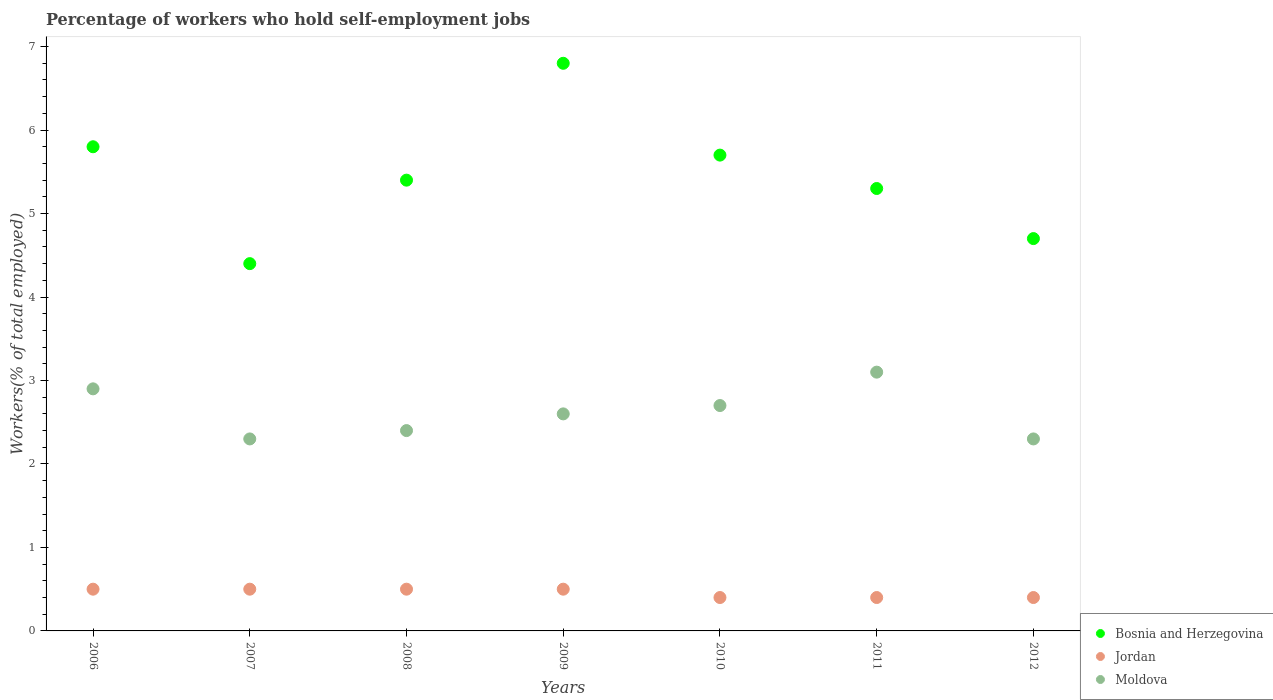How many different coloured dotlines are there?
Make the answer very short. 3. Is the number of dotlines equal to the number of legend labels?
Give a very brief answer. Yes. What is the percentage of self-employed workers in Jordan in 2011?
Keep it short and to the point. 0.4. Across all years, what is the maximum percentage of self-employed workers in Moldova?
Give a very brief answer. 3.1. Across all years, what is the minimum percentage of self-employed workers in Jordan?
Your response must be concise. 0.4. What is the total percentage of self-employed workers in Jordan in the graph?
Offer a very short reply. 3.2. What is the difference between the percentage of self-employed workers in Bosnia and Herzegovina in 2006 and that in 2011?
Give a very brief answer. 0.5. What is the difference between the percentage of self-employed workers in Jordan in 2011 and the percentage of self-employed workers in Moldova in 2010?
Offer a very short reply. -2.3. What is the average percentage of self-employed workers in Moldova per year?
Keep it short and to the point. 2.61. In the year 2012, what is the difference between the percentage of self-employed workers in Bosnia and Herzegovina and percentage of self-employed workers in Moldova?
Provide a succinct answer. 2.4. What is the ratio of the percentage of self-employed workers in Moldova in 2006 to that in 2008?
Provide a short and direct response. 1.21. Is the percentage of self-employed workers in Bosnia and Herzegovina in 2006 less than that in 2009?
Your response must be concise. Yes. Is the difference between the percentage of self-employed workers in Bosnia and Herzegovina in 2007 and 2008 greater than the difference between the percentage of self-employed workers in Moldova in 2007 and 2008?
Provide a succinct answer. No. What is the difference between the highest and the second highest percentage of self-employed workers in Moldova?
Ensure brevity in your answer.  0.2. What is the difference between the highest and the lowest percentage of self-employed workers in Bosnia and Herzegovina?
Make the answer very short. 2.4. In how many years, is the percentage of self-employed workers in Moldova greater than the average percentage of self-employed workers in Moldova taken over all years?
Make the answer very short. 3. How many dotlines are there?
Offer a very short reply. 3. Where does the legend appear in the graph?
Your answer should be very brief. Bottom right. How many legend labels are there?
Your answer should be very brief. 3. How are the legend labels stacked?
Your answer should be very brief. Vertical. What is the title of the graph?
Provide a succinct answer. Percentage of workers who hold self-employment jobs. Does "Norway" appear as one of the legend labels in the graph?
Give a very brief answer. No. What is the label or title of the Y-axis?
Provide a succinct answer. Workers(% of total employed). What is the Workers(% of total employed) in Bosnia and Herzegovina in 2006?
Offer a very short reply. 5.8. What is the Workers(% of total employed) of Jordan in 2006?
Keep it short and to the point. 0.5. What is the Workers(% of total employed) of Moldova in 2006?
Make the answer very short. 2.9. What is the Workers(% of total employed) in Bosnia and Herzegovina in 2007?
Your answer should be very brief. 4.4. What is the Workers(% of total employed) in Jordan in 2007?
Provide a short and direct response. 0.5. What is the Workers(% of total employed) of Moldova in 2007?
Offer a terse response. 2.3. What is the Workers(% of total employed) in Bosnia and Herzegovina in 2008?
Your response must be concise. 5.4. What is the Workers(% of total employed) in Moldova in 2008?
Your answer should be compact. 2.4. What is the Workers(% of total employed) in Bosnia and Herzegovina in 2009?
Your answer should be very brief. 6.8. What is the Workers(% of total employed) in Moldova in 2009?
Your answer should be compact. 2.6. What is the Workers(% of total employed) in Bosnia and Herzegovina in 2010?
Ensure brevity in your answer.  5.7. What is the Workers(% of total employed) of Jordan in 2010?
Make the answer very short. 0.4. What is the Workers(% of total employed) in Moldova in 2010?
Make the answer very short. 2.7. What is the Workers(% of total employed) in Bosnia and Herzegovina in 2011?
Offer a very short reply. 5.3. What is the Workers(% of total employed) in Jordan in 2011?
Provide a short and direct response. 0.4. What is the Workers(% of total employed) in Moldova in 2011?
Your response must be concise. 3.1. What is the Workers(% of total employed) of Bosnia and Herzegovina in 2012?
Keep it short and to the point. 4.7. What is the Workers(% of total employed) of Jordan in 2012?
Your response must be concise. 0.4. What is the Workers(% of total employed) in Moldova in 2012?
Give a very brief answer. 2.3. Across all years, what is the maximum Workers(% of total employed) of Bosnia and Herzegovina?
Make the answer very short. 6.8. Across all years, what is the maximum Workers(% of total employed) of Jordan?
Offer a terse response. 0.5. Across all years, what is the maximum Workers(% of total employed) in Moldova?
Keep it short and to the point. 3.1. Across all years, what is the minimum Workers(% of total employed) of Bosnia and Herzegovina?
Keep it short and to the point. 4.4. Across all years, what is the minimum Workers(% of total employed) in Jordan?
Keep it short and to the point. 0.4. Across all years, what is the minimum Workers(% of total employed) in Moldova?
Your response must be concise. 2.3. What is the total Workers(% of total employed) of Bosnia and Herzegovina in the graph?
Offer a very short reply. 38.1. What is the total Workers(% of total employed) in Jordan in the graph?
Provide a succinct answer. 3.2. What is the total Workers(% of total employed) of Moldova in the graph?
Offer a terse response. 18.3. What is the difference between the Workers(% of total employed) of Bosnia and Herzegovina in 2006 and that in 2007?
Your response must be concise. 1.4. What is the difference between the Workers(% of total employed) of Bosnia and Herzegovina in 2006 and that in 2008?
Your answer should be compact. 0.4. What is the difference between the Workers(% of total employed) in Jordan in 2006 and that in 2008?
Ensure brevity in your answer.  0. What is the difference between the Workers(% of total employed) in Jordan in 2006 and that in 2009?
Make the answer very short. 0. What is the difference between the Workers(% of total employed) of Moldova in 2006 and that in 2009?
Give a very brief answer. 0.3. What is the difference between the Workers(% of total employed) of Bosnia and Herzegovina in 2006 and that in 2010?
Provide a short and direct response. 0.1. What is the difference between the Workers(% of total employed) in Jordan in 2006 and that in 2010?
Your response must be concise. 0.1. What is the difference between the Workers(% of total employed) of Bosnia and Herzegovina in 2006 and that in 2011?
Your answer should be very brief. 0.5. What is the difference between the Workers(% of total employed) of Moldova in 2006 and that in 2012?
Provide a short and direct response. 0.6. What is the difference between the Workers(% of total employed) of Moldova in 2007 and that in 2009?
Offer a very short reply. -0.3. What is the difference between the Workers(% of total employed) of Jordan in 2007 and that in 2010?
Provide a succinct answer. 0.1. What is the difference between the Workers(% of total employed) of Moldova in 2007 and that in 2010?
Ensure brevity in your answer.  -0.4. What is the difference between the Workers(% of total employed) of Bosnia and Herzegovina in 2007 and that in 2012?
Your answer should be very brief. -0.3. What is the difference between the Workers(% of total employed) of Bosnia and Herzegovina in 2008 and that in 2010?
Your response must be concise. -0.3. What is the difference between the Workers(% of total employed) in Jordan in 2008 and that in 2010?
Your answer should be very brief. 0.1. What is the difference between the Workers(% of total employed) of Jordan in 2008 and that in 2011?
Your response must be concise. 0.1. What is the difference between the Workers(% of total employed) of Moldova in 2008 and that in 2011?
Your answer should be very brief. -0.7. What is the difference between the Workers(% of total employed) in Bosnia and Herzegovina in 2008 and that in 2012?
Ensure brevity in your answer.  0.7. What is the difference between the Workers(% of total employed) of Jordan in 2008 and that in 2012?
Give a very brief answer. 0.1. What is the difference between the Workers(% of total employed) in Bosnia and Herzegovina in 2009 and that in 2011?
Ensure brevity in your answer.  1.5. What is the difference between the Workers(% of total employed) in Bosnia and Herzegovina in 2010 and that in 2011?
Ensure brevity in your answer.  0.4. What is the difference between the Workers(% of total employed) of Jordan in 2010 and that in 2011?
Make the answer very short. 0. What is the difference between the Workers(% of total employed) in Bosnia and Herzegovina in 2010 and that in 2012?
Provide a short and direct response. 1. What is the difference between the Workers(% of total employed) in Jordan in 2010 and that in 2012?
Provide a succinct answer. 0. What is the difference between the Workers(% of total employed) of Moldova in 2010 and that in 2012?
Offer a terse response. 0.4. What is the difference between the Workers(% of total employed) in Bosnia and Herzegovina in 2011 and that in 2012?
Provide a short and direct response. 0.6. What is the difference between the Workers(% of total employed) in Jordan in 2011 and that in 2012?
Give a very brief answer. 0. What is the difference between the Workers(% of total employed) of Moldova in 2011 and that in 2012?
Provide a succinct answer. 0.8. What is the difference between the Workers(% of total employed) of Bosnia and Herzegovina in 2006 and the Workers(% of total employed) of Jordan in 2007?
Make the answer very short. 5.3. What is the difference between the Workers(% of total employed) in Bosnia and Herzegovina in 2006 and the Workers(% of total employed) in Moldova in 2007?
Your answer should be very brief. 3.5. What is the difference between the Workers(% of total employed) in Bosnia and Herzegovina in 2006 and the Workers(% of total employed) in Jordan in 2008?
Your answer should be very brief. 5.3. What is the difference between the Workers(% of total employed) in Bosnia and Herzegovina in 2006 and the Workers(% of total employed) in Moldova in 2008?
Make the answer very short. 3.4. What is the difference between the Workers(% of total employed) of Jordan in 2006 and the Workers(% of total employed) of Moldova in 2008?
Give a very brief answer. -1.9. What is the difference between the Workers(% of total employed) in Bosnia and Herzegovina in 2006 and the Workers(% of total employed) in Jordan in 2009?
Offer a very short reply. 5.3. What is the difference between the Workers(% of total employed) of Bosnia and Herzegovina in 2006 and the Workers(% of total employed) of Moldova in 2009?
Offer a terse response. 3.2. What is the difference between the Workers(% of total employed) in Jordan in 2006 and the Workers(% of total employed) in Moldova in 2009?
Your answer should be very brief. -2.1. What is the difference between the Workers(% of total employed) of Bosnia and Herzegovina in 2006 and the Workers(% of total employed) of Moldova in 2010?
Provide a short and direct response. 3.1. What is the difference between the Workers(% of total employed) in Bosnia and Herzegovina in 2006 and the Workers(% of total employed) in Jordan in 2011?
Your answer should be very brief. 5.4. What is the difference between the Workers(% of total employed) of Bosnia and Herzegovina in 2006 and the Workers(% of total employed) of Moldova in 2011?
Your response must be concise. 2.7. What is the difference between the Workers(% of total employed) of Jordan in 2006 and the Workers(% of total employed) of Moldova in 2011?
Keep it short and to the point. -2.6. What is the difference between the Workers(% of total employed) in Bosnia and Herzegovina in 2006 and the Workers(% of total employed) in Jordan in 2012?
Keep it short and to the point. 5.4. What is the difference between the Workers(% of total employed) in Bosnia and Herzegovina in 2006 and the Workers(% of total employed) in Moldova in 2012?
Make the answer very short. 3.5. What is the difference between the Workers(% of total employed) in Bosnia and Herzegovina in 2007 and the Workers(% of total employed) in Jordan in 2008?
Provide a short and direct response. 3.9. What is the difference between the Workers(% of total employed) of Bosnia and Herzegovina in 2007 and the Workers(% of total employed) of Moldova in 2008?
Offer a very short reply. 2. What is the difference between the Workers(% of total employed) of Bosnia and Herzegovina in 2007 and the Workers(% of total employed) of Moldova in 2009?
Keep it short and to the point. 1.8. What is the difference between the Workers(% of total employed) in Bosnia and Herzegovina in 2007 and the Workers(% of total employed) in Jordan in 2010?
Give a very brief answer. 4. What is the difference between the Workers(% of total employed) of Bosnia and Herzegovina in 2007 and the Workers(% of total employed) of Moldova in 2010?
Provide a succinct answer. 1.7. What is the difference between the Workers(% of total employed) in Jordan in 2007 and the Workers(% of total employed) in Moldova in 2010?
Give a very brief answer. -2.2. What is the difference between the Workers(% of total employed) in Bosnia and Herzegovina in 2007 and the Workers(% of total employed) in Moldova in 2011?
Offer a very short reply. 1.3. What is the difference between the Workers(% of total employed) of Jordan in 2007 and the Workers(% of total employed) of Moldova in 2011?
Keep it short and to the point. -2.6. What is the difference between the Workers(% of total employed) of Bosnia and Herzegovina in 2007 and the Workers(% of total employed) of Jordan in 2012?
Offer a terse response. 4. What is the difference between the Workers(% of total employed) in Bosnia and Herzegovina in 2007 and the Workers(% of total employed) in Moldova in 2012?
Keep it short and to the point. 2.1. What is the difference between the Workers(% of total employed) of Jordan in 2008 and the Workers(% of total employed) of Moldova in 2009?
Make the answer very short. -2.1. What is the difference between the Workers(% of total employed) of Bosnia and Herzegovina in 2008 and the Workers(% of total employed) of Jordan in 2010?
Offer a very short reply. 5. What is the difference between the Workers(% of total employed) of Bosnia and Herzegovina in 2008 and the Workers(% of total employed) of Moldova in 2010?
Provide a succinct answer. 2.7. What is the difference between the Workers(% of total employed) of Bosnia and Herzegovina in 2008 and the Workers(% of total employed) of Jordan in 2011?
Your answer should be compact. 5. What is the difference between the Workers(% of total employed) in Bosnia and Herzegovina in 2008 and the Workers(% of total employed) in Jordan in 2012?
Offer a terse response. 5. What is the difference between the Workers(% of total employed) of Bosnia and Herzegovina in 2008 and the Workers(% of total employed) of Moldova in 2012?
Your response must be concise. 3.1. What is the difference between the Workers(% of total employed) of Bosnia and Herzegovina in 2009 and the Workers(% of total employed) of Jordan in 2010?
Your response must be concise. 6.4. What is the difference between the Workers(% of total employed) of Bosnia and Herzegovina in 2009 and the Workers(% of total employed) of Jordan in 2011?
Provide a succinct answer. 6.4. What is the difference between the Workers(% of total employed) of Bosnia and Herzegovina in 2009 and the Workers(% of total employed) of Moldova in 2011?
Ensure brevity in your answer.  3.7. What is the difference between the Workers(% of total employed) in Jordan in 2009 and the Workers(% of total employed) in Moldova in 2012?
Provide a succinct answer. -1.8. What is the difference between the Workers(% of total employed) of Bosnia and Herzegovina in 2010 and the Workers(% of total employed) of Jordan in 2011?
Keep it short and to the point. 5.3. What is the difference between the Workers(% of total employed) of Bosnia and Herzegovina in 2010 and the Workers(% of total employed) of Moldova in 2011?
Your response must be concise. 2.6. What is the difference between the Workers(% of total employed) of Jordan in 2010 and the Workers(% of total employed) of Moldova in 2011?
Your response must be concise. -2.7. What is the difference between the Workers(% of total employed) in Bosnia and Herzegovina in 2011 and the Workers(% of total employed) in Jordan in 2012?
Give a very brief answer. 4.9. What is the average Workers(% of total employed) in Bosnia and Herzegovina per year?
Your response must be concise. 5.44. What is the average Workers(% of total employed) in Jordan per year?
Provide a short and direct response. 0.46. What is the average Workers(% of total employed) of Moldova per year?
Make the answer very short. 2.61. In the year 2008, what is the difference between the Workers(% of total employed) of Bosnia and Herzegovina and Workers(% of total employed) of Jordan?
Provide a succinct answer. 4.9. In the year 2008, what is the difference between the Workers(% of total employed) in Jordan and Workers(% of total employed) in Moldova?
Offer a terse response. -1.9. In the year 2009, what is the difference between the Workers(% of total employed) in Jordan and Workers(% of total employed) in Moldova?
Offer a very short reply. -2.1. In the year 2011, what is the difference between the Workers(% of total employed) of Bosnia and Herzegovina and Workers(% of total employed) of Jordan?
Ensure brevity in your answer.  4.9. In the year 2011, what is the difference between the Workers(% of total employed) of Bosnia and Herzegovina and Workers(% of total employed) of Moldova?
Offer a very short reply. 2.2. What is the ratio of the Workers(% of total employed) of Bosnia and Herzegovina in 2006 to that in 2007?
Provide a short and direct response. 1.32. What is the ratio of the Workers(% of total employed) of Jordan in 2006 to that in 2007?
Provide a short and direct response. 1. What is the ratio of the Workers(% of total employed) in Moldova in 2006 to that in 2007?
Your answer should be very brief. 1.26. What is the ratio of the Workers(% of total employed) of Bosnia and Herzegovina in 2006 to that in 2008?
Ensure brevity in your answer.  1.07. What is the ratio of the Workers(% of total employed) in Moldova in 2006 to that in 2008?
Ensure brevity in your answer.  1.21. What is the ratio of the Workers(% of total employed) in Bosnia and Herzegovina in 2006 to that in 2009?
Offer a very short reply. 0.85. What is the ratio of the Workers(% of total employed) in Jordan in 2006 to that in 2009?
Your answer should be very brief. 1. What is the ratio of the Workers(% of total employed) of Moldova in 2006 to that in 2009?
Give a very brief answer. 1.12. What is the ratio of the Workers(% of total employed) in Bosnia and Herzegovina in 2006 to that in 2010?
Offer a very short reply. 1.02. What is the ratio of the Workers(% of total employed) in Jordan in 2006 to that in 2010?
Ensure brevity in your answer.  1.25. What is the ratio of the Workers(% of total employed) in Moldova in 2006 to that in 2010?
Ensure brevity in your answer.  1.07. What is the ratio of the Workers(% of total employed) in Bosnia and Herzegovina in 2006 to that in 2011?
Give a very brief answer. 1.09. What is the ratio of the Workers(% of total employed) in Moldova in 2006 to that in 2011?
Offer a terse response. 0.94. What is the ratio of the Workers(% of total employed) in Bosnia and Herzegovina in 2006 to that in 2012?
Provide a succinct answer. 1.23. What is the ratio of the Workers(% of total employed) of Moldova in 2006 to that in 2012?
Offer a terse response. 1.26. What is the ratio of the Workers(% of total employed) in Bosnia and Herzegovina in 2007 to that in 2008?
Make the answer very short. 0.81. What is the ratio of the Workers(% of total employed) in Jordan in 2007 to that in 2008?
Ensure brevity in your answer.  1. What is the ratio of the Workers(% of total employed) of Moldova in 2007 to that in 2008?
Provide a succinct answer. 0.96. What is the ratio of the Workers(% of total employed) of Bosnia and Herzegovina in 2007 to that in 2009?
Give a very brief answer. 0.65. What is the ratio of the Workers(% of total employed) of Moldova in 2007 to that in 2009?
Your answer should be compact. 0.88. What is the ratio of the Workers(% of total employed) in Bosnia and Herzegovina in 2007 to that in 2010?
Your response must be concise. 0.77. What is the ratio of the Workers(% of total employed) of Jordan in 2007 to that in 2010?
Your response must be concise. 1.25. What is the ratio of the Workers(% of total employed) in Moldova in 2007 to that in 2010?
Provide a succinct answer. 0.85. What is the ratio of the Workers(% of total employed) of Bosnia and Herzegovina in 2007 to that in 2011?
Your answer should be compact. 0.83. What is the ratio of the Workers(% of total employed) of Jordan in 2007 to that in 2011?
Your answer should be very brief. 1.25. What is the ratio of the Workers(% of total employed) of Moldova in 2007 to that in 2011?
Give a very brief answer. 0.74. What is the ratio of the Workers(% of total employed) of Bosnia and Herzegovina in 2007 to that in 2012?
Keep it short and to the point. 0.94. What is the ratio of the Workers(% of total employed) in Moldova in 2007 to that in 2012?
Your answer should be compact. 1. What is the ratio of the Workers(% of total employed) in Bosnia and Herzegovina in 2008 to that in 2009?
Provide a succinct answer. 0.79. What is the ratio of the Workers(% of total employed) of Jordan in 2008 to that in 2009?
Offer a very short reply. 1. What is the ratio of the Workers(% of total employed) in Bosnia and Herzegovina in 2008 to that in 2010?
Ensure brevity in your answer.  0.95. What is the ratio of the Workers(% of total employed) of Bosnia and Herzegovina in 2008 to that in 2011?
Give a very brief answer. 1.02. What is the ratio of the Workers(% of total employed) of Moldova in 2008 to that in 2011?
Your response must be concise. 0.77. What is the ratio of the Workers(% of total employed) of Bosnia and Herzegovina in 2008 to that in 2012?
Provide a succinct answer. 1.15. What is the ratio of the Workers(% of total employed) of Jordan in 2008 to that in 2012?
Offer a terse response. 1.25. What is the ratio of the Workers(% of total employed) of Moldova in 2008 to that in 2012?
Give a very brief answer. 1.04. What is the ratio of the Workers(% of total employed) of Bosnia and Herzegovina in 2009 to that in 2010?
Keep it short and to the point. 1.19. What is the ratio of the Workers(% of total employed) in Moldova in 2009 to that in 2010?
Provide a succinct answer. 0.96. What is the ratio of the Workers(% of total employed) of Bosnia and Herzegovina in 2009 to that in 2011?
Make the answer very short. 1.28. What is the ratio of the Workers(% of total employed) in Moldova in 2009 to that in 2011?
Provide a succinct answer. 0.84. What is the ratio of the Workers(% of total employed) of Bosnia and Herzegovina in 2009 to that in 2012?
Keep it short and to the point. 1.45. What is the ratio of the Workers(% of total employed) of Jordan in 2009 to that in 2012?
Keep it short and to the point. 1.25. What is the ratio of the Workers(% of total employed) in Moldova in 2009 to that in 2012?
Provide a short and direct response. 1.13. What is the ratio of the Workers(% of total employed) in Bosnia and Herzegovina in 2010 to that in 2011?
Offer a very short reply. 1.08. What is the ratio of the Workers(% of total employed) in Moldova in 2010 to that in 2011?
Keep it short and to the point. 0.87. What is the ratio of the Workers(% of total employed) in Bosnia and Herzegovina in 2010 to that in 2012?
Make the answer very short. 1.21. What is the ratio of the Workers(% of total employed) in Jordan in 2010 to that in 2012?
Keep it short and to the point. 1. What is the ratio of the Workers(% of total employed) in Moldova in 2010 to that in 2012?
Give a very brief answer. 1.17. What is the ratio of the Workers(% of total employed) in Bosnia and Herzegovina in 2011 to that in 2012?
Make the answer very short. 1.13. What is the ratio of the Workers(% of total employed) in Jordan in 2011 to that in 2012?
Ensure brevity in your answer.  1. What is the ratio of the Workers(% of total employed) of Moldova in 2011 to that in 2012?
Offer a very short reply. 1.35. What is the difference between the highest and the second highest Workers(% of total employed) in Bosnia and Herzegovina?
Offer a very short reply. 1. What is the difference between the highest and the second highest Workers(% of total employed) in Jordan?
Offer a terse response. 0. What is the difference between the highest and the second highest Workers(% of total employed) of Moldova?
Give a very brief answer. 0.2. 